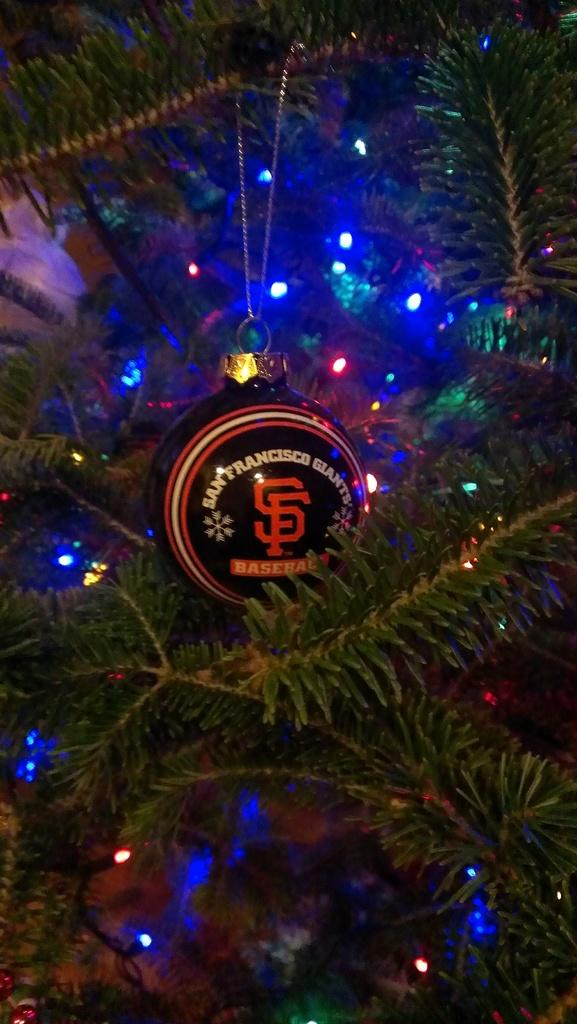What type of tree is in the image? There is a Christmas tree in the image. What decoration can be seen on the Christmas tree? The Christmas tree has a decorative ball. What additional feature is present on the Christmas tree? The Christmas tree has lights. What reward is the Christmas tree receiving for being well-decorated in the image? There is no indication in the image that the Christmas tree is receiving a reward for being well-decorated. 